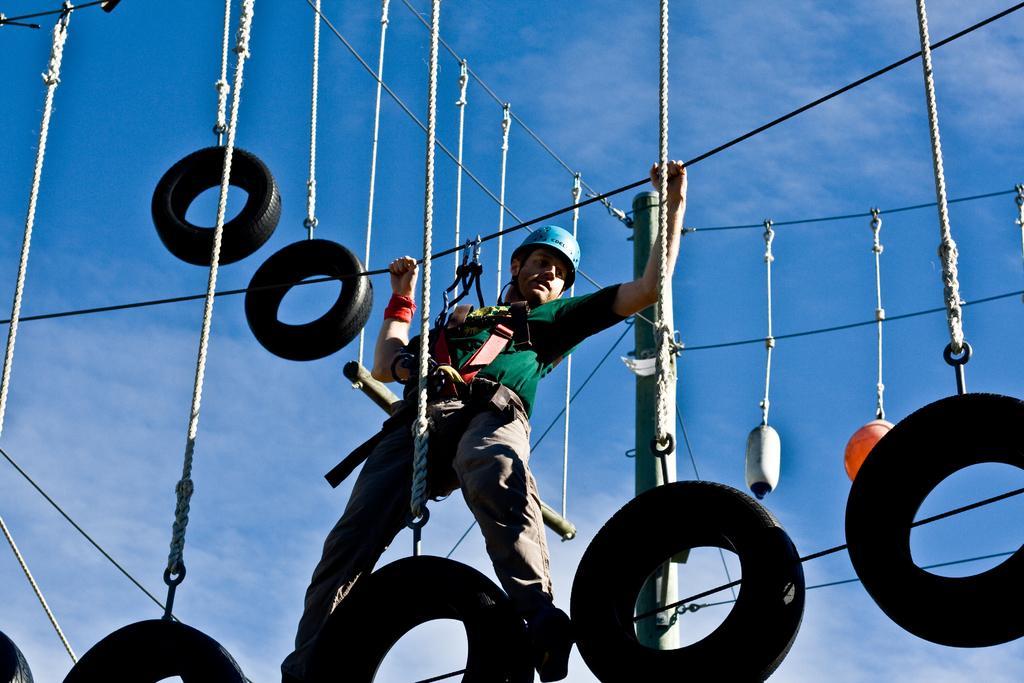How would you summarize this image in a sentence or two? In this image we can see wires hanging with ropes. Also we can see person wearing helmet is walking on rope. Also he is holding ropes. In the background there is sky with clouds. 